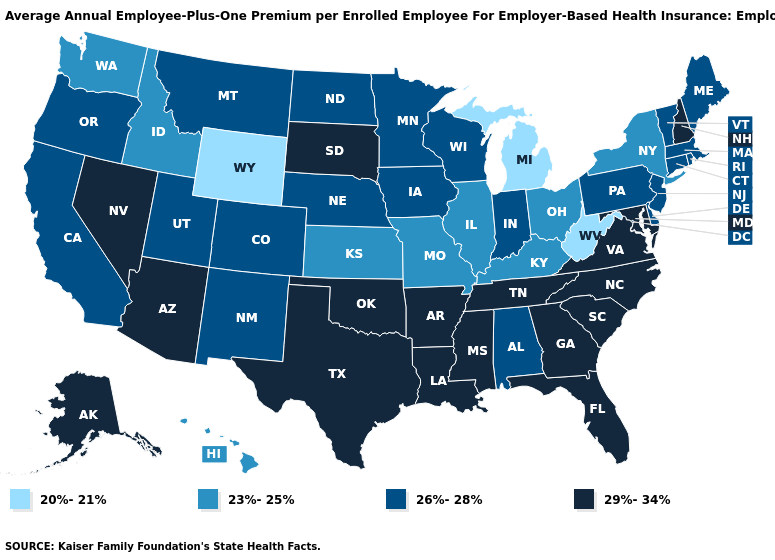Does New Hampshire have the highest value in the USA?
Give a very brief answer. Yes. Name the states that have a value in the range 23%-25%?
Be succinct. Hawaii, Idaho, Illinois, Kansas, Kentucky, Missouri, New York, Ohio, Washington. Does Kentucky have a lower value than Oregon?
Be succinct. Yes. Name the states that have a value in the range 20%-21%?
Be succinct. Michigan, West Virginia, Wyoming. Does New Jersey have the highest value in the Northeast?
Keep it brief. No. Which states have the lowest value in the USA?
Give a very brief answer. Michigan, West Virginia, Wyoming. Does Michigan have the lowest value in the USA?
Concise answer only. Yes. Name the states that have a value in the range 26%-28%?
Give a very brief answer. Alabama, California, Colorado, Connecticut, Delaware, Indiana, Iowa, Maine, Massachusetts, Minnesota, Montana, Nebraska, New Jersey, New Mexico, North Dakota, Oregon, Pennsylvania, Rhode Island, Utah, Vermont, Wisconsin. Does the map have missing data?
Answer briefly. No. Does Iowa have the highest value in the USA?
Answer briefly. No. What is the value of Pennsylvania?
Short answer required. 26%-28%. Does Rhode Island have the lowest value in the Northeast?
Give a very brief answer. No. What is the lowest value in the West?
Write a very short answer. 20%-21%. Does the map have missing data?
Concise answer only. No. Does Nevada have the highest value in the West?
Concise answer only. Yes. 